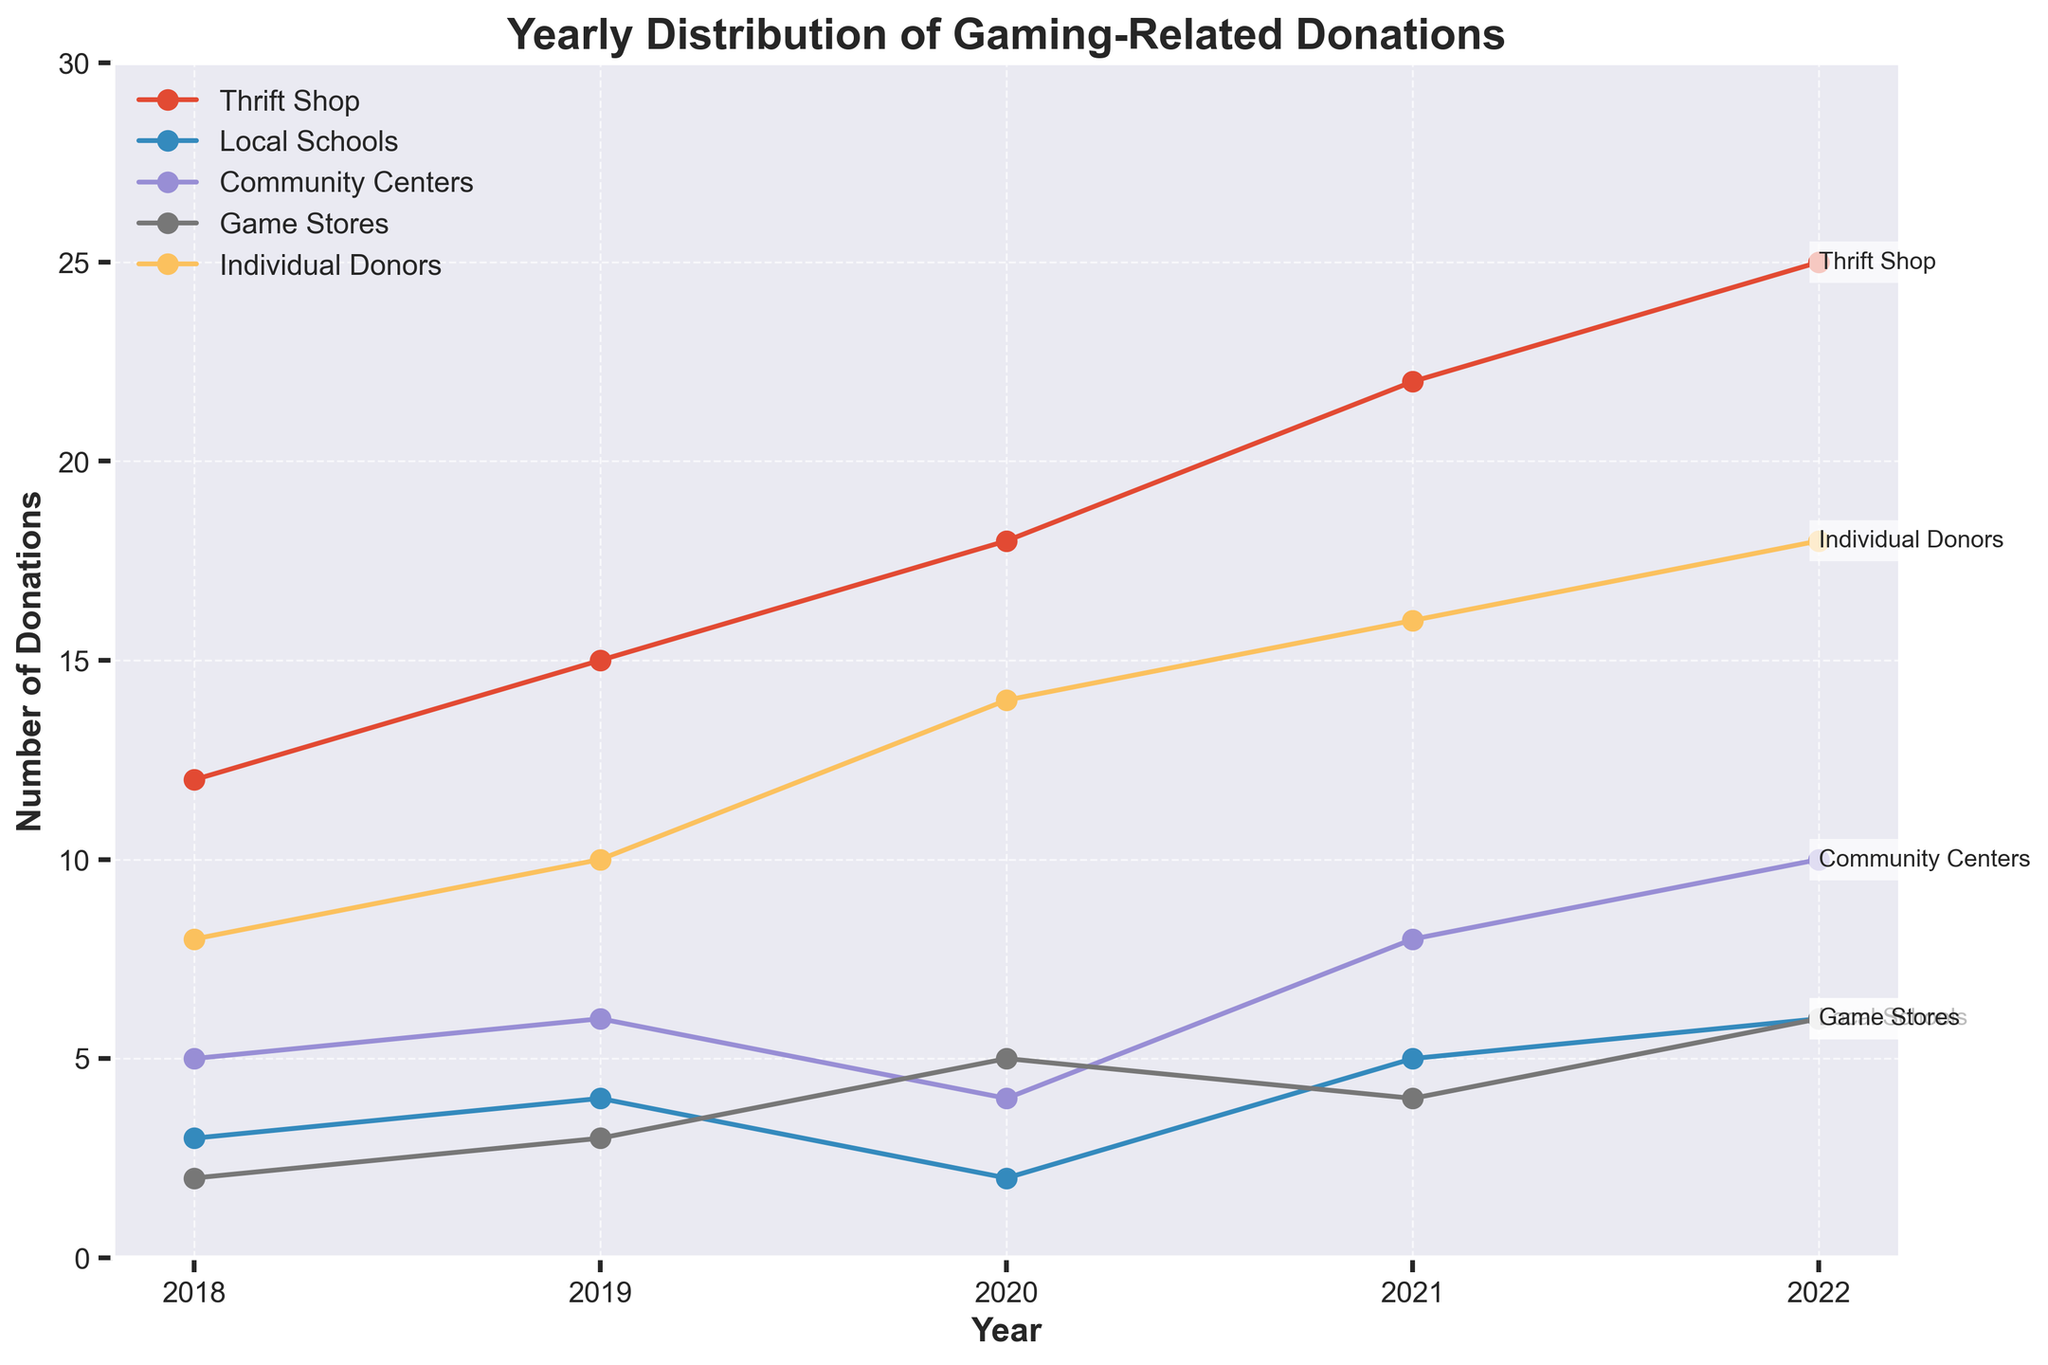what is the overall trend for the number of donations from Individual Donors from 2018 to 2022? From the figure, the line representing Individual Donors shows consistent upward movement year over year. This indicates that the number of donations from Individual Donors has been increasing each year.
Answer: Increasing Which source had the highest number of donations in 2022? In the figure, all the lines end at the point representing 2022. Among these, the line for Individual Donors is the highest. Therefore, Individual Donors had the highest number of donations in 2022.
Answer: Individual Donors How did the number of donations from Local Schools change from 2018 to 2022? By observing the line for Local Schools, it starts at 3 in 2018 and increases to 6 in 2022. Though there are slight fluctuations, the overall change shows an increase.
Answer: Increased What is the difference in the number of donations from Community Centers between the years 2019 and 2020? The number of donations from Community Centers in 2019 is 6, and in 2020 it is 4. The difference is calculated as 6 - 4 = 2.
Answer: 2 Which two sources contributed equally in 2021? Observing the lines at the point representing 2021, the Thrift Shop and Individual Donors both have the same value of donations, which is 16.
Answer: Thrift Shop and Individual Donors What is the average number of donations from Game Stores over the years 2020 to 2022? The donations from Game Stores over these years are 5 in 2020, 4 in 2021, and 6 in 2022. Adding these values: 5 + 4 + 6 = 15. Dividing by 3 (number of years) gives the average: 15 / 3 = 5.
Answer: 5 How many total donations did the Thrift Shop receive from 2018 to 2022? Summing the donations from the Thrift Shop for each year: 12 (2018) + 15 (2019) + 18 (2020) + 22 (2021) + 25 (2022) = 92.
Answer: 92 Did donations from Community Centers ever match those from Local Schools in any year? By comparing the figures year by year, in 2021, both Local Schools and Community Centers have the same number of donations, which is 5.
Answer: Yes, in 2021 What is the median number of donations from Individual Donors across the five years? The donations from Individual Donors for each year are 8, 10, 14, 16, and 18. To find the median, we order the values: 8, 10, 14, 16, 18. The median is the middle value, which is 14.
Answer: 14 